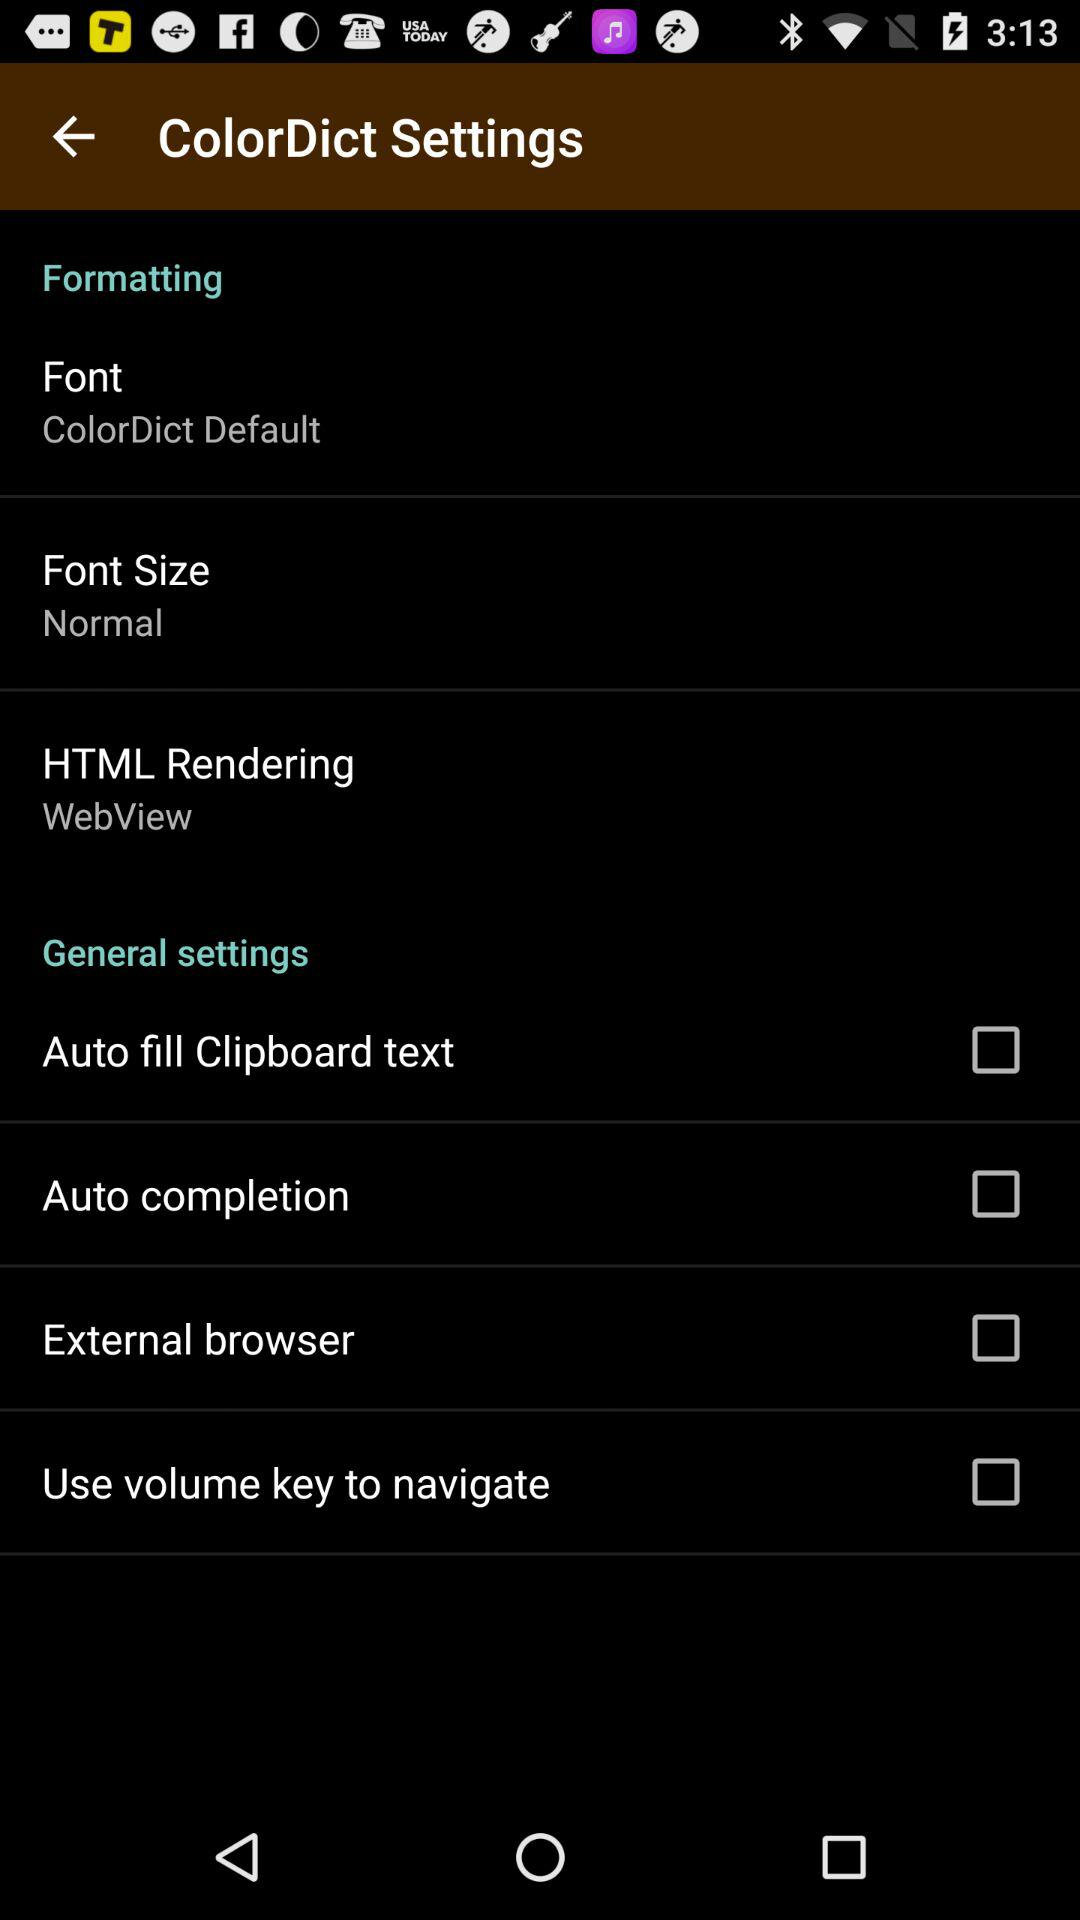What is the status of the "Auto completion"? The status is "off". 